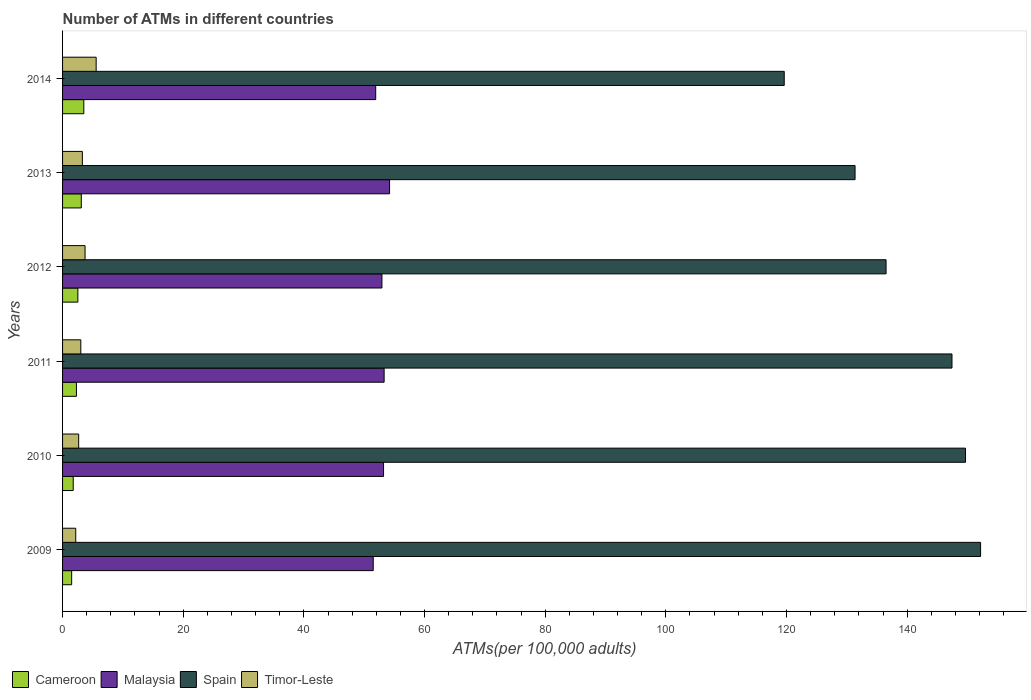How many different coloured bars are there?
Give a very brief answer. 4. Are the number of bars on each tick of the Y-axis equal?
Provide a short and direct response. Yes. How many bars are there on the 4th tick from the top?
Give a very brief answer. 4. What is the label of the 5th group of bars from the top?
Offer a terse response. 2010. In how many cases, is the number of bars for a given year not equal to the number of legend labels?
Provide a succinct answer. 0. What is the number of ATMs in Spain in 2012?
Your answer should be very brief. 136.51. Across all years, what is the maximum number of ATMs in Timor-Leste?
Ensure brevity in your answer.  5.57. Across all years, what is the minimum number of ATMs in Malaysia?
Ensure brevity in your answer.  51.5. In which year was the number of ATMs in Timor-Leste minimum?
Your response must be concise. 2009. What is the total number of ATMs in Malaysia in the graph?
Offer a terse response. 317.07. What is the difference between the number of ATMs in Malaysia in 2009 and that in 2013?
Give a very brief answer. -2.71. What is the difference between the number of ATMs in Cameroon in 2009 and the number of ATMs in Malaysia in 2014?
Your answer should be compact. -50.4. What is the average number of ATMs in Malaysia per year?
Provide a succinct answer. 52.84. In the year 2013, what is the difference between the number of ATMs in Timor-Leste and number of ATMs in Spain?
Ensure brevity in your answer.  -128.09. What is the ratio of the number of ATMs in Malaysia in 2013 to that in 2014?
Your answer should be compact. 1.04. Is the number of ATMs in Cameroon in 2009 less than that in 2013?
Offer a terse response. Yes. Is the difference between the number of ATMs in Timor-Leste in 2010 and 2013 greater than the difference between the number of ATMs in Spain in 2010 and 2013?
Your answer should be very brief. No. What is the difference between the highest and the second highest number of ATMs in Cameroon?
Make the answer very short. 0.42. What is the difference between the highest and the lowest number of ATMs in Timor-Leste?
Make the answer very short. 3.39. In how many years, is the number of ATMs in Spain greater than the average number of ATMs in Spain taken over all years?
Your response must be concise. 3. Is the sum of the number of ATMs in Cameroon in 2009 and 2014 greater than the maximum number of ATMs in Spain across all years?
Your response must be concise. No. What does the 4th bar from the top in 2010 represents?
Ensure brevity in your answer.  Cameroon. What does the 4th bar from the bottom in 2013 represents?
Provide a short and direct response. Timor-Leste. Are all the bars in the graph horizontal?
Keep it short and to the point. Yes. Does the graph contain any zero values?
Your answer should be compact. No. Where does the legend appear in the graph?
Make the answer very short. Bottom left. How many legend labels are there?
Give a very brief answer. 4. What is the title of the graph?
Keep it short and to the point. Number of ATMs in different countries. What is the label or title of the X-axis?
Offer a very short reply. ATMs(per 100,0 adults). What is the ATMs(per 100,000 adults) in Cameroon in 2009?
Ensure brevity in your answer.  1.51. What is the ATMs(per 100,000 adults) of Malaysia in 2009?
Make the answer very short. 51.5. What is the ATMs(per 100,000 adults) in Spain in 2009?
Give a very brief answer. 152.18. What is the ATMs(per 100,000 adults) of Timor-Leste in 2009?
Keep it short and to the point. 2.18. What is the ATMs(per 100,000 adults) of Cameroon in 2010?
Offer a terse response. 1.77. What is the ATMs(per 100,000 adults) in Malaysia in 2010?
Your answer should be very brief. 53.21. What is the ATMs(per 100,000 adults) in Spain in 2010?
Ensure brevity in your answer.  149.68. What is the ATMs(per 100,000 adults) of Timor-Leste in 2010?
Provide a short and direct response. 2.67. What is the ATMs(per 100,000 adults) of Cameroon in 2011?
Your answer should be compact. 2.3. What is the ATMs(per 100,000 adults) of Malaysia in 2011?
Keep it short and to the point. 53.31. What is the ATMs(per 100,000 adults) in Spain in 2011?
Keep it short and to the point. 147.44. What is the ATMs(per 100,000 adults) in Timor-Leste in 2011?
Ensure brevity in your answer.  3.02. What is the ATMs(per 100,000 adults) of Cameroon in 2012?
Your answer should be very brief. 2.53. What is the ATMs(per 100,000 adults) of Malaysia in 2012?
Provide a succinct answer. 52.94. What is the ATMs(per 100,000 adults) in Spain in 2012?
Provide a succinct answer. 136.51. What is the ATMs(per 100,000 adults) of Timor-Leste in 2012?
Offer a terse response. 3.73. What is the ATMs(per 100,000 adults) in Cameroon in 2013?
Provide a succinct answer. 3.1. What is the ATMs(per 100,000 adults) in Malaysia in 2013?
Offer a terse response. 54.21. What is the ATMs(per 100,000 adults) in Spain in 2013?
Offer a terse response. 131.37. What is the ATMs(per 100,000 adults) in Timor-Leste in 2013?
Your answer should be compact. 3.28. What is the ATMs(per 100,000 adults) in Cameroon in 2014?
Provide a short and direct response. 3.52. What is the ATMs(per 100,000 adults) in Malaysia in 2014?
Make the answer very short. 51.91. What is the ATMs(per 100,000 adults) in Spain in 2014?
Offer a very short reply. 119.63. What is the ATMs(per 100,000 adults) of Timor-Leste in 2014?
Provide a short and direct response. 5.57. Across all years, what is the maximum ATMs(per 100,000 adults) of Cameroon?
Keep it short and to the point. 3.52. Across all years, what is the maximum ATMs(per 100,000 adults) of Malaysia?
Your response must be concise. 54.21. Across all years, what is the maximum ATMs(per 100,000 adults) of Spain?
Ensure brevity in your answer.  152.18. Across all years, what is the maximum ATMs(per 100,000 adults) of Timor-Leste?
Make the answer very short. 5.57. Across all years, what is the minimum ATMs(per 100,000 adults) of Cameroon?
Ensure brevity in your answer.  1.51. Across all years, what is the minimum ATMs(per 100,000 adults) in Malaysia?
Provide a succinct answer. 51.5. Across all years, what is the minimum ATMs(per 100,000 adults) of Spain?
Offer a terse response. 119.63. Across all years, what is the minimum ATMs(per 100,000 adults) in Timor-Leste?
Offer a very short reply. 2.18. What is the total ATMs(per 100,000 adults) of Cameroon in the graph?
Give a very brief answer. 14.73. What is the total ATMs(per 100,000 adults) of Malaysia in the graph?
Your answer should be compact. 317.07. What is the total ATMs(per 100,000 adults) in Spain in the graph?
Offer a terse response. 836.8. What is the total ATMs(per 100,000 adults) of Timor-Leste in the graph?
Your answer should be very brief. 20.46. What is the difference between the ATMs(per 100,000 adults) of Cameroon in 2009 and that in 2010?
Provide a short and direct response. -0.26. What is the difference between the ATMs(per 100,000 adults) in Malaysia in 2009 and that in 2010?
Keep it short and to the point. -1.71. What is the difference between the ATMs(per 100,000 adults) of Timor-Leste in 2009 and that in 2010?
Ensure brevity in your answer.  -0.49. What is the difference between the ATMs(per 100,000 adults) in Cameroon in 2009 and that in 2011?
Your answer should be compact. -0.79. What is the difference between the ATMs(per 100,000 adults) of Malaysia in 2009 and that in 2011?
Provide a succinct answer. -1.81. What is the difference between the ATMs(per 100,000 adults) of Spain in 2009 and that in 2011?
Provide a short and direct response. 4.74. What is the difference between the ATMs(per 100,000 adults) in Timor-Leste in 2009 and that in 2011?
Provide a succinct answer. -0.84. What is the difference between the ATMs(per 100,000 adults) in Cameroon in 2009 and that in 2012?
Provide a succinct answer. -1.03. What is the difference between the ATMs(per 100,000 adults) in Malaysia in 2009 and that in 2012?
Offer a very short reply. -1.44. What is the difference between the ATMs(per 100,000 adults) of Spain in 2009 and that in 2012?
Provide a short and direct response. 15.67. What is the difference between the ATMs(per 100,000 adults) of Timor-Leste in 2009 and that in 2012?
Ensure brevity in your answer.  -1.55. What is the difference between the ATMs(per 100,000 adults) in Cameroon in 2009 and that in 2013?
Make the answer very short. -1.6. What is the difference between the ATMs(per 100,000 adults) of Malaysia in 2009 and that in 2013?
Your answer should be compact. -2.71. What is the difference between the ATMs(per 100,000 adults) in Spain in 2009 and that in 2013?
Your response must be concise. 20.81. What is the difference between the ATMs(per 100,000 adults) of Timor-Leste in 2009 and that in 2013?
Your response must be concise. -1.1. What is the difference between the ATMs(per 100,000 adults) in Cameroon in 2009 and that in 2014?
Offer a very short reply. -2.01. What is the difference between the ATMs(per 100,000 adults) in Malaysia in 2009 and that in 2014?
Your response must be concise. -0.41. What is the difference between the ATMs(per 100,000 adults) of Spain in 2009 and that in 2014?
Give a very brief answer. 32.55. What is the difference between the ATMs(per 100,000 adults) in Timor-Leste in 2009 and that in 2014?
Keep it short and to the point. -3.39. What is the difference between the ATMs(per 100,000 adults) of Cameroon in 2010 and that in 2011?
Keep it short and to the point. -0.53. What is the difference between the ATMs(per 100,000 adults) of Malaysia in 2010 and that in 2011?
Provide a short and direct response. -0.1. What is the difference between the ATMs(per 100,000 adults) in Spain in 2010 and that in 2011?
Give a very brief answer. 2.24. What is the difference between the ATMs(per 100,000 adults) of Timor-Leste in 2010 and that in 2011?
Ensure brevity in your answer.  -0.35. What is the difference between the ATMs(per 100,000 adults) of Cameroon in 2010 and that in 2012?
Provide a succinct answer. -0.77. What is the difference between the ATMs(per 100,000 adults) of Malaysia in 2010 and that in 2012?
Your answer should be compact. 0.27. What is the difference between the ATMs(per 100,000 adults) of Spain in 2010 and that in 2012?
Give a very brief answer. 13.17. What is the difference between the ATMs(per 100,000 adults) of Timor-Leste in 2010 and that in 2012?
Keep it short and to the point. -1.06. What is the difference between the ATMs(per 100,000 adults) in Cameroon in 2010 and that in 2013?
Ensure brevity in your answer.  -1.34. What is the difference between the ATMs(per 100,000 adults) of Malaysia in 2010 and that in 2013?
Your answer should be compact. -1. What is the difference between the ATMs(per 100,000 adults) in Spain in 2010 and that in 2013?
Offer a very short reply. 18.31. What is the difference between the ATMs(per 100,000 adults) of Timor-Leste in 2010 and that in 2013?
Offer a very short reply. -0.61. What is the difference between the ATMs(per 100,000 adults) in Cameroon in 2010 and that in 2014?
Give a very brief answer. -1.76. What is the difference between the ATMs(per 100,000 adults) of Malaysia in 2010 and that in 2014?
Provide a succinct answer. 1.3. What is the difference between the ATMs(per 100,000 adults) in Spain in 2010 and that in 2014?
Provide a short and direct response. 30.05. What is the difference between the ATMs(per 100,000 adults) in Timor-Leste in 2010 and that in 2014?
Your answer should be very brief. -2.9. What is the difference between the ATMs(per 100,000 adults) in Cameroon in 2011 and that in 2012?
Provide a succinct answer. -0.24. What is the difference between the ATMs(per 100,000 adults) of Malaysia in 2011 and that in 2012?
Provide a succinct answer. 0.36. What is the difference between the ATMs(per 100,000 adults) in Spain in 2011 and that in 2012?
Keep it short and to the point. 10.93. What is the difference between the ATMs(per 100,000 adults) in Timor-Leste in 2011 and that in 2012?
Offer a terse response. -0.7. What is the difference between the ATMs(per 100,000 adults) in Cameroon in 2011 and that in 2013?
Offer a terse response. -0.81. What is the difference between the ATMs(per 100,000 adults) of Malaysia in 2011 and that in 2013?
Your answer should be compact. -0.9. What is the difference between the ATMs(per 100,000 adults) in Spain in 2011 and that in 2013?
Provide a succinct answer. 16.07. What is the difference between the ATMs(per 100,000 adults) in Timor-Leste in 2011 and that in 2013?
Ensure brevity in your answer.  -0.26. What is the difference between the ATMs(per 100,000 adults) of Cameroon in 2011 and that in 2014?
Ensure brevity in your answer.  -1.22. What is the difference between the ATMs(per 100,000 adults) of Malaysia in 2011 and that in 2014?
Your answer should be compact. 1.4. What is the difference between the ATMs(per 100,000 adults) in Spain in 2011 and that in 2014?
Offer a very short reply. 27.81. What is the difference between the ATMs(per 100,000 adults) in Timor-Leste in 2011 and that in 2014?
Keep it short and to the point. -2.54. What is the difference between the ATMs(per 100,000 adults) of Cameroon in 2012 and that in 2013?
Provide a succinct answer. -0.57. What is the difference between the ATMs(per 100,000 adults) in Malaysia in 2012 and that in 2013?
Offer a terse response. -1.27. What is the difference between the ATMs(per 100,000 adults) in Spain in 2012 and that in 2013?
Your response must be concise. 5.14. What is the difference between the ATMs(per 100,000 adults) in Timor-Leste in 2012 and that in 2013?
Provide a short and direct response. 0.45. What is the difference between the ATMs(per 100,000 adults) of Cameroon in 2012 and that in 2014?
Keep it short and to the point. -0.99. What is the difference between the ATMs(per 100,000 adults) of Malaysia in 2012 and that in 2014?
Provide a short and direct response. 1.03. What is the difference between the ATMs(per 100,000 adults) in Spain in 2012 and that in 2014?
Ensure brevity in your answer.  16.88. What is the difference between the ATMs(per 100,000 adults) of Timor-Leste in 2012 and that in 2014?
Provide a succinct answer. -1.84. What is the difference between the ATMs(per 100,000 adults) of Cameroon in 2013 and that in 2014?
Your answer should be very brief. -0.42. What is the difference between the ATMs(per 100,000 adults) of Malaysia in 2013 and that in 2014?
Offer a terse response. 2.3. What is the difference between the ATMs(per 100,000 adults) in Spain in 2013 and that in 2014?
Your response must be concise. 11.74. What is the difference between the ATMs(per 100,000 adults) of Timor-Leste in 2013 and that in 2014?
Offer a very short reply. -2.29. What is the difference between the ATMs(per 100,000 adults) of Cameroon in 2009 and the ATMs(per 100,000 adults) of Malaysia in 2010?
Offer a very short reply. -51.7. What is the difference between the ATMs(per 100,000 adults) of Cameroon in 2009 and the ATMs(per 100,000 adults) of Spain in 2010?
Your answer should be compact. -148.17. What is the difference between the ATMs(per 100,000 adults) of Cameroon in 2009 and the ATMs(per 100,000 adults) of Timor-Leste in 2010?
Give a very brief answer. -1.16. What is the difference between the ATMs(per 100,000 adults) of Malaysia in 2009 and the ATMs(per 100,000 adults) of Spain in 2010?
Keep it short and to the point. -98.18. What is the difference between the ATMs(per 100,000 adults) of Malaysia in 2009 and the ATMs(per 100,000 adults) of Timor-Leste in 2010?
Keep it short and to the point. 48.83. What is the difference between the ATMs(per 100,000 adults) of Spain in 2009 and the ATMs(per 100,000 adults) of Timor-Leste in 2010?
Offer a very short reply. 149.51. What is the difference between the ATMs(per 100,000 adults) of Cameroon in 2009 and the ATMs(per 100,000 adults) of Malaysia in 2011?
Your response must be concise. -51.8. What is the difference between the ATMs(per 100,000 adults) of Cameroon in 2009 and the ATMs(per 100,000 adults) of Spain in 2011?
Keep it short and to the point. -145.93. What is the difference between the ATMs(per 100,000 adults) in Cameroon in 2009 and the ATMs(per 100,000 adults) in Timor-Leste in 2011?
Make the answer very short. -1.52. What is the difference between the ATMs(per 100,000 adults) of Malaysia in 2009 and the ATMs(per 100,000 adults) of Spain in 2011?
Your response must be concise. -95.94. What is the difference between the ATMs(per 100,000 adults) in Malaysia in 2009 and the ATMs(per 100,000 adults) in Timor-Leste in 2011?
Your answer should be compact. 48.47. What is the difference between the ATMs(per 100,000 adults) of Spain in 2009 and the ATMs(per 100,000 adults) of Timor-Leste in 2011?
Keep it short and to the point. 149.15. What is the difference between the ATMs(per 100,000 adults) of Cameroon in 2009 and the ATMs(per 100,000 adults) of Malaysia in 2012?
Provide a short and direct response. -51.43. What is the difference between the ATMs(per 100,000 adults) in Cameroon in 2009 and the ATMs(per 100,000 adults) in Spain in 2012?
Offer a very short reply. -135. What is the difference between the ATMs(per 100,000 adults) in Cameroon in 2009 and the ATMs(per 100,000 adults) in Timor-Leste in 2012?
Offer a terse response. -2.22. What is the difference between the ATMs(per 100,000 adults) of Malaysia in 2009 and the ATMs(per 100,000 adults) of Spain in 2012?
Your response must be concise. -85.01. What is the difference between the ATMs(per 100,000 adults) in Malaysia in 2009 and the ATMs(per 100,000 adults) in Timor-Leste in 2012?
Provide a succinct answer. 47.77. What is the difference between the ATMs(per 100,000 adults) in Spain in 2009 and the ATMs(per 100,000 adults) in Timor-Leste in 2012?
Your answer should be very brief. 148.45. What is the difference between the ATMs(per 100,000 adults) in Cameroon in 2009 and the ATMs(per 100,000 adults) in Malaysia in 2013?
Your answer should be compact. -52.7. What is the difference between the ATMs(per 100,000 adults) in Cameroon in 2009 and the ATMs(per 100,000 adults) in Spain in 2013?
Ensure brevity in your answer.  -129.86. What is the difference between the ATMs(per 100,000 adults) in Cameroon in 2009 and the ATMs(per 100,000 adults) in Timor-Leste in 2013?
Give a very brief answer. -1.77. What is the difference between the ATMs(per 100,000 adults) in Malaysia in 2009 and the ATMs(per 100,000 adults) in Spain in 2013?
Your answer should be compact. -79.87. What is the difference between the ATMs(per 100,000 adults) in Malaysia in 2009 and the ATMs(per 100,000 adults) in Timor-Leste in 2013?
Make the answer very short. 48.22. What is the difference between the ATMs(per 100,000 adults) in Spain in 2009 and the ATMs(per 100,000 adults) in Timor-Leste in 2013?
Offer a terse response. 148.9. What is the difference between the ATMs(per 100,000 adults) of Cameroon in 2009 and the ATMs(per 100,000 adults) of Malaysia in 2014?
Give a very brief answer. -50.4. What is the difference between the ATMs(per 100,000 adults) in Cameroon in 2009 and the ATMs(per 100,000 adults) in Spain in 2014?
Offer a terse response. -118.12. What is the difference between the ATMs(per 100,000 adults) of Cameroon in 2009 and the ATMs(per 100,000 adults) of Timor-Leste in 2014?
Give a very brief answer. -4.06. What is the difference between the ATMs(per 100,000 adults) in Malaysia in 2009 and the ATMs(per 100,000 adults) in Spain in 2014?
Your response must be concise. -68.13. What is the difference between the ATMs(per 100,000 adults) in Malaysia in 2009 and the ATMs(per 100,000 adults) in Timor-Leste in 2014?
Offer a very short reply. 45.93. What is the difference between the ATMs(per 100,000 adults) of Spain in 2009 and the ATMs(per 100,000 adults) of Timor-Leste in 2014?
Keep it short and to the point. 146.61. What is the difference between the ATMs(per 100,000 adults) of Cameroon in 2010 and the ATMs(per 100,000 adults) of Malaysia in 2011?
Offer a terse response. -51.54. What is the difference between the ATMs(per 100,000 adults) of Cameroon in 2010 and the ATMs(per 100,000 adults) of Spain in 2011?
Your response must be concise. -145.67. What is the difference between the ATMs(per 100,000 adults) in Cameroon in 2010 and the ATMs(per 100,000 adults) in Timor-Leste in 2011?
Ensure brevity in your answer.  -1.26. What is the difference between the ATMs(per 100,000 adults) of Malaysia in 2010 and the ATMs(per 100,000 adults) of Spain in 2011?
Provide a succinct answer. -94.23. What is the difference between the ATMs(per 100,000 adults) in Malaysia in 2010 and the ATMs(per 100,000 adults) in Timor-Leste in 2011?
Ensure brevity in your answer.  50.18. What is the difference between the ATMs(per 100,000 adults) in Spain in 2010 and the ATMs(per 100,000 adults) in Timor-Leste in 2011?
Provide a short and direct response. 146.65. What is the difference between the ATMs(per 100,000 adults) of Cameroon in 2010 and the ATMs(per 100,000 adults) of Malaysia in 2012?
Offer a terse response. -51.18. What is the difference between the ATMs(per 100,000 adults) in Cameroon in 2010 and the ATMs(per 100,000 adults) in Spain in 2012?
Offer a terse response. -134.74. What is the difference between the ATMs(per 100,000 adults) in Cameroon in 2010 and the ATMs(per 100,000 adults) in Timor-Leste in 2012?
Offer a very short reply. -1.96. What is the difference between the ATMs(per 100,000 adults) of Malaysia in 2010 and the ATMs(per 100,000 adults) of Spain in 2012?
Offer a terse response. -83.3. What is the difference between the ATMs(per 100,000 adults) in Malaysia in 2010 and the ATMs(per 100,000 adults) in Timor-Leste in 2012?
Offer a terse response. 49.48. What is the difference between the ATMs(per 100,000 adults) of Spain in 2010 and the ATMs(per 100,000 adults) of Timor-Leste in 2012?
Your answer should be compact. 145.95. What is the difference between the ATMs(per 100,000 adults) of Cameroon in 2010 and the ATMs(per 100,000 adults) of Malaysia in 2013?
Offer a very short reply. -52.44. What is the difference between the ATMs(per 100,000 adults) in Cameroon in 2010 and the ATMs(per 100,000 adults) in Spain in 2013?
Keep it short and to the point. -129.6. What is the difference between the ATMs(per 100,000 adults) in Cameroon in 2010 and the ATMs(per 100,000 adults) in Timor-Leste in 2013?
Provide a succinct answer. -1.52. What is the difference between the ATMs(per 100,000 adults) in Malaysia in 2010 and the ATMs(per 100,000 adults) in Spain in 2013?
Offer a terse response. -78.16. What is the difference between the ATMs(per 100,000 adults) in Malaysia in 2010 and the ATMs(per 100,000 adults) in Timor-Leste in 2013?
Give a very brief answer. 49.93. What is the difference between the ATMs(per 100,000 adults) of Spain in 2010 and the ATMs(per 100,000 adults) of Timor-Leste in 2013?
Provide a succinct answer. 146.4. What is the difference between the ATMs(per 100,000 adults) of Cameroon in 2010 and the ATMs(per 100,000 adults) of Malaysia in 2014?
Provide a succinct answer. -50.14. What is the difference between the ATMs(per 100,000 adults) of Cameroon in 2010 and the ATMs(per 100,000 adults) of Spain in 2014?
Offer a very short reply. -117.86. What is the difference between the ATMs(per 100,000 adults) in Cameroon in 2010 and the ATMs(per 100,000 adults) in Timor-Leste in 2014?
Make the answer very short. -3.8. What is the difference between the ATMs(per 100,000 adults) of Malaysia in 2010 and the ATMs(per 100,000 adults) of Spain in 2014?
Your answer should be very brief. -66.42. What is the difference between the ATMs(per 100,000 adults) of Malaysia in 2010 and the ATMs(per 100,000 adults) of Timor-Leste in 2014?
Provide a succinct answer. 47.64. What is the difference between the ATMs(per 100,000 adults) of Spain in 2010 and the ATMs(per 100,000 adults) of Timor-Leste in 2014?
Ensure brevity in your answer.  144.11. What is the difference between the ATMs(per 100,000 adults) in Cameroon in 2011 and the ATMs(per 100,000 adults) in Malaysia in 2012?
Provide a short and direct response. -50.64. What is the difference between the ATMs(per 100,000 adults) in Cameroon in 2011 and the ATMs(per 100,000 adults) in Spain in 2012?
Offer a very short reply. -134.21. What is the difference between the ATMs(per 100,000 adults) of Cameroon in 2011 and the ATMs(per 100,000 adults) of Timor-Leste in 2012?
Provide a succinct answer. -1.43. What is the difference between the ATMs(per 100,000 adults) in Malaysia in 2011 and the ATMs(per 100,000 adults) in Spain in 2012?
Give a very brief answer. -83.2. What is the difference between the ATMs(per 100,000 adults) of Malaysia in 2011 and the ATMs(per 100,000 adults) of Timor-Leste in 2012?
Give a very brief answer. 49.58. What is the difference between the ATMs(per 100,000 adults) of Spain in 2011 and the ATMs(per 100,000 adults) of Timor-Leste in 2012?
Your response must be concise. 143.71. What is the difference between the ATMs(per 100,000 adults) in Cameroon in 2011 and the ATMs(per 100,000 adults) in Malaysia in 2013?
Provide a succinct answer. -51.91. What is the difference between the ATMs(per 100,000 adults) of Cameroon in 2011 and the ATMs(per 100,000 adults) of Spain in 2013?
Your response must be concise. -129.07. What is the difference between the ATMs(per 100,000 adults) in Cameroon in 2011 and the ATMs(per 100,000 adults) in Timor-Leste in 2013?
Your response must be concise. -0.98. What is the difference between the ATMs(per 100,000 adults) in Malaysia in 2011 and the ATMs(per 100,000 adults) in Spain in 2013?
Offer a terse response. -78.06. What is the difference between the ATMs(per 100,000 adults) in Malaysia in 2011 and the ATMs(per 100,000 adults) in Timor-Leste in 2013?
Keep it short and to the point. 50.02. What is the difference between the ATMs(per 100,000 adults) in Spain in 2011 and the ATMs(per 100,000 adults) in Timor-Leste in 2013?
Give a very brief answer. 144.15. What is the difference between the ATMs(per 100,000 adults) of Cameroon in 2011 and the ATMs(per 100,000 adults) of Malaysia in 2014?
Give a very brief answer. -49.61. What is the difference between the ATMs(per 100,000 adults) of Cameroon in 2011 and the ATMs(per 100,000 adults) of Spain in 2014?
Provide a short and direct response. -117.33. What is the difference between the ATMs(per 100,000 adults) in Cameroon in 2011 and the ATMs(per 100,000 adults) in Timor-Leste in 2014?
Give a very brief answer. -3.27. What is the difference between the ATMs(per 100,000 adults) of Malaysia in 2011 and the ATMs(per 100,000 adults) of Spain in 2014?
Keep it short and to the point. -66.32. What is the difference between the ATMs(per 100,000 adults) in Malaysia in 2011 and the ATMs(per 100,000 adults) in Timor-Leste in 2014?
Make the answer very short. 47.74. What is the difference between the ATMs(per 100,000 adults) in Spain in 2011 and the ATMs(per 100,000 adults) in Timor-Leste in 2014?
Provide a short and direct response. 141.87. What is the difference between the ATMs(per 100,000 adults) of Cameroon in 2012 and the ATMs(per 100,000 adults) of Malaysia in 2013?
Make the answer very short. -51.67. What is the difference between the ATMs(per 100,000 adults) in Cameroon in 2012 and the ATMs(per 100,000 adults) in Spain in 2013?
Provide a short and direct response. -128.83. What is the difference between the ATMs(per 100,000 adults) in Cameroon in 2012 and the ATMs(per 100,000 adults) in Timor-Leste in 2013?
Make the answer very short. -0.75. What is the difference between the ATMs(per 100,000 adults) in Malaysia in 2012 and the ATMs(per 100,000 adults) in Spain in 2013?
Your answer should be compact. -78.43. What is the difference between the ATMs(per 100,000 adults) of Malaysia in 2012 and the ATMs(per 100,000 adults) of Timor-Leste in 2013?
Provide a succinct answer. 49.66. What is the difference between the ATMs(per 100,000 adults) in Spain in 2012 and the ATMs(per 100,000 adults) in Timor-Leste in 2013?
Provide a short and direct response. 133.23. What is the difference between the ATMs(per 100,000 adults) in Cameroon in 2012 and the ATMs(per 100,000 adults) in Malaysia in 2014?
Make the answer very short. -49.37. What is the difference between the ATMs(per 100,000 adults) of Cameroon in 2012 and the ATMs(per 100,000 adults) of Spain in 2014?
Give a very brief answer. -117.09. What is the difference between the ATMs(per 100,000 adults) of Cameroon in 2012 and the ATMs(per 100,000 adults) of Timor-Leste in 2014?
Give a very brief answer. -3.03. What is the difference between the ATMs(per 100,000 adults) of Malaysia in 2012 and the ATMs(per 100,000 adults) of Spain in 2014?
Ensure brevity in your answer.  -66.69. What is the difference between the ATMs(per 100,000 adults) in Malaysia in 2012 and the ATMs(per 100,000 adults) in Timor-Leste in 2014?
Your answer should be very brief. 47.37. What is the difference between the ATMs(per 100,000 adults) in Spain in 2012 and the ATMs(per 100,000 adults) in Timor-Leste in 2014?
Give a very brief answer. 130.94. What is the difference between the ATMs(per 100,000 adults) of Cameroon in 2013 and the ATMs(per 100,000 adults) of Malaysia in 2014?
Make the answer very short. -48.8. What is the difference between the ATMs(per 100,000 adults) in Cameroon in 2013 and the ATMs(per 100,000 adults) in Spain in 2014?
Provide a succinct answer. -116.52. What is the difference between the ATMs(per 100,000 adults) of Cameroon in 2013 and the ATMs(per 100,000 adults) of Timor-Leste in 2014?
Your answer should be very brief. -2.46. What is the difference between the ATMs(per 100,000 adults) in Malaysia in 2013 and the ATMs(per 100,000 adults) in Spain in 2014?
Ensure brevity in your answer.  -65.42. What is the difference between the ATMs(per 100,000 adults) of Malaysia in 2013 and the ATMs(per 100,000 adults) of Timor-Leste in 2014?
Offer a very short reply. 48.64. What is the difference between the ATMs(per 100,000 adults) of Spain in 2013 and the ATMs(per 100,000 adults) of Timor-Leste in 2014?
Keep it short and to the point. 125.8. What is the average ATMs(per 100,000 adults) of Cameroon per year?
Keep it short and to the point. 2.46. What is the average ATMs(per 100,000 adults) of Malaysia per year?
Make the answer very short. 52.84. What is the average ATMs(per 100,000 adults) of Spain per year?
Offer a terse response. 139.47. What is the average ATMs(per 100,000 adults) of Timor-Leste per year?
Your response must be concise. 3.41. In the year 2009, what is the difference between the ATMs(per 100,000 adults) of Cameroon and ATMs(per 100,000 adults) of Malaysia?
Your answer should be very brief. -49.99. In the year 2009, what is the difference between the ATMs(per 100,000 adults) of Cameroon and ATMs(per 100,000 adults) of Spain?
Ensure brevity in your answer.  -150.67. In the year 2009, what is the difference between the ATMs(per 100,000 adults) of Cameroon and ATMs(per 100,000 adults) of Timor-Leste?
Ensure brevity in your answer.  -0.67. In the year 2009, what is the difference between the ATMs(per 100,000 adults) in Malaysia and ATMs(per 100,000 adults) in Spain?
Your answer should be very brief. -100.68. In the year 2009, what is the difference between the ATMs(per 100,000 adults) in Malaysia and ATMs(per 100,000 adults) in Timor-Leste?
Your answer should be compact. 49.32. In the year 2009, what is the difference between the ATMs(per 100,000 adults) of Spain and ATMs(per 100,000 adults) of Timor-Leste?
Make the answer very short. 150. In the year 2010, what is the difference between the ATMs(per 100,000 adults) of Cameroon and ATMs(per 100,000 adults) of Malaysia?
Offer a terse response. -51.44. In the year 2010, what is the difference between the ATMs(per 100,000 adults) in Cameroon and ATMs(per 100,000 adults) in Spain?
Provide a short and direct response. -147.91. In the year 2010, what is the difference between the ATMs(per 100,000 adults) of Cameroon and ATMs(per 100,000 adults) of Timor-Leste?
Make the answer very short. -0.91. In the year 2010, what is the difference between the ATMs(per 100,000 adults) of Malaysia and ATMs(per 100,000 adults) of Spain?
Give a very brief answer. -96.47. In the year 2010, what is the difference between the ATMs(per 100,000 adults) of Malaysia and ATMs(per 100,000 adults) of Timor-Leste?
Provide a succinct answer. 50.54. In the year 2010, what is the difference between the ATMs(per 100,000 adults) of Spain and ATMs(per 100,000 adults) of Timor-Leste?
Keep it short and to the point. 147.01. In the year 2011, what is the difference between the ATMs(per 100,000 adults) in Cameroon and ATMs(per 100,000 adults) in Malaysia?
Keep it short and to the point. -51.01. In the year 2011, what is the difference between the ATMs(per 100,000 adults) in Cameroon and ATMs(per 100,000 adults) in Spain?
Your answer should be compact. -145.14. In the year 2011, what is the difference between the ATMs(per 100,000 adults) of Cameroon and ATMs(per 100,000 adults) of Timor-Leste?
Ensure brevity in your answer.  -0.73. In the year 2011, what is the difference between the ATMs(per 100,000 adults) of Malaysia and ATMs(per 100,000 adults) of Spain?
Offer a terse response. -94.13. In the year 2011, what is the difference between the ATMs(per 100,000 adults) in Malaysia and ATMs(per 100,000 adults) in Timor-Leste?
Provide a succinct answer. 50.28. In the year 2011, what is the difference between the ATMs(per 100,000 adults) in Spain and ATMs(per 100,000 adults) in Timor-Leste?
Offer a very short reply. 144.41. In the year 2012, what is the difference between the ATMs(per 100,000 adults) in Cameroon and ATMs(per 100,000 adults) in Malaysia?
Provide a succinct answer. -50.41. In the year 2012, what is the difference between the ATMs(per 100,000 adults) of Cameroon and ATMs(per 100,000 adults) of Spain?
Your response must be concise. -133.97. In the year 2012, what is the difference between the ATMs(per 100,000 adults) in Cameroon and ATMs(per 100,000 adults) in Timor-Leste?
Keep it short and to the point. -1.2. In the year 2012, what is the difference between the ATMs(per 100,000 adults) of Malaysia and ATMs(per 100,000 adults) of Spain?
Your response must be concise. -83.57. In the year 2012, what is the difference between the ATMs(per 100,000 adults) of Malaysia and ATMs(per 100,000 adults) of Timor-Leste?
Offer a terse response. 49.21. In the year 2012, what is the difference between the ATMs(per 100,000 adults) of Spain and ATMs(per 100,000 adults) of Timor-Leste?
Provide a short and direct response. 132.78. In the year 2013, what is the difference between the ATMs(per 100,000 adults) of Cameroon and ATMs(per 100,000 adults) of Malaysia?
Keep it short and to the point. -51.1. In the year 2013, what is the difference between the ATMs(per 100,000 adults) in Cameroon and ATMs(per 100,000 adults) in Spain?
Provide a succinct answer. -128.26. In the year 2013, what is the difference between the ATMs(per 100,000 adults) in Cameroon and ATMs(per 100,000 adults) in Timor-Leste?
Give a very brief answer. -0.18. In the year 2013, what is the difference between the ATMs(per 100,000 adults) in Malaysia and ATMs(per 100,000 adults) in Spain?
Your answer should be very brief. -77.16. In the year 2013, what is the difference between the ATMs(per 100,000 adults) of Malaysia and ATMs(per 100,000 adults) of Timor-Leste?
Offer a terse response. 50.92. In the year 2013, what is the difference between the ATMs(per 100,000 adults) in Spain and ATMs(per 100,000 adults) in Timor-Leste?
Your response must be concise. 128.09. In the year 2014, what is the difference between the ATMs(per 100,000 adults) in Cameroon and ATMs(per 100,000 adults) in Malaysia?
Make the answer very short. -48.39. In the year 2014, what is the difference between the ATMs(per 100,000 adults) of Cameroon and ATMs(per 100,000 adults) of Spain?
Offer a very short reply. -116.11. In the year 2014, what is the difference between the ATMs(per 100,000 adults) in Cameroon and ATMs(per 100,000 adults) in Timor-Leste?
Give a very brief answer. -2.05. In the year 2014, what is the difference between the ATMs(per 100,000 adults) in Malaysia and ATMs(per 100,000 adults) in Spain?
Keep it short and to the point. -67.72. In the year 2014, what is the difference between the ATMs(per 100,000 adults) in Malaysia and ATMs(per 100,000 adults) in Timor-Leste?
Provide a succinct answer. 46.34. In the year 2014, what is the difference between the ATMs(per 100,000 adults) in Spain and ATMs(per 100,000 adults) in Timor-Leste?
Your answer should be compact. 114.06. What is the ratio of the ATMs(per 100,000 adults) of Cameroon in 2009 to that in 2010?
Give a very brief answer. 0.85. What is the ratio of the ATMs(per 100,000 adults) in Malaysia in 2009 to that in 2010?
Provide a succinct answer. 0.97. What is the ratio of the ATMs(per 100,000 adults) of Spain in 2009 to that in 2010?
Your response must be concise. 1.02. What is the ratio of the ATMs(per 100,000 adults) of Timor-Leste in 2009 to that in 2010?
Ensure brevity in your answer.  0.82. What is the ratio of the ATMs(per 100,000 adults) of Cameroon in 2009 to that in 2011?
Offer a terse response. 0.66. What is the ratio of the ATMs(per 100,000 adults) of Malaysia in 2009 to that in 2011?
Keep it short and to the point. 0.97. What is the ratio of the ATMs(per 100,000 adults) of Spain in 2009 to that in 2011?
Your response must be concise. 1.03. What is the ratio of the ATMs(per 100,000 adults) in Timor-Leste in 2009 to that in 2011?
Ensure brevity in your answer.  0.72. What is the ratio of the ATMs(per 100,000 adults) of Cameroon in 2009 to that in 2012?
Give a very brief answer. 0.59. What is the ratio of the ATMs(per 100,000 adults) in Malaysia in 2009 to that in 2012?
Your answer should be compact. 0.97. What is the ratio of the ATMs(per 100,000 adults) in Spain in 2009 to that in 2012?
Provide a succinct answer. 1.11. What is the ratio of the ATMs(per 100,000 adults) of Timor-Leste in 2009 to that in 2012?
Your response must be concise. 0.58. What is the ratio of the ATMs(per 100,000 adults) in Cameroon in 2009 to that in 2013?
Keep it short and to the point. 0.49. What is the ratio of the ATMs(per 100,000 adults) in Malaysia in 2009 to that in 2013?
Your answer should be compact. 0.95. What is the ratio of the ATMs(per 100,000 adults) in Spain in 2009 to that in 2013?
Ensure brevity in your answer.  1.16. What is the ratio of the ATMs(per 100,000 adults) in Timor-Leste in 2009 to that in 2013?
Give a very brief answer. 0.66. What is the ratio of the ATMs(per 100,000 adults) of Cameroon in 2009 to that in 2014?
Offer a very short reply. 0.43. What is the ratio of the ATMs(per 100,000 adults) in Spain in 2009 to that in 2014?
Make the answer very short. 1.27. What is the ratio of the ATMs(per 100,000 adults) in Timor-Leste in 2009 to that in 2014?
Your answer should be compact. 0.39. What is the ratio of the ATMs(per 100,000 adults) in Cameroon in 2010 to that in 2011?
Provide a short and direct response. 0.77. What is the ratio of the ATMs(per 100,000 adults) of Spain in 2010 to that in 2011?
Give a very brief answer. 1.02. What is the ratio of the ATMs(per 100,000 adults) of Timor-Leste in 2010 to that in 2011?
Offer a terse response. 0.88. What is the ratio of the ATMs(per 100,000 adults) in Cameroon in 2010 to that in 2012?
Ensure brevity in your answer.  0.7. What is the ratio of the ATMs(per 100,000 adults) of Malaysia in 2010 to that in 2012?
Make the answer very short. 1. What is the ratio of the ATMs(per 100,000 adults) of Spain in 2010 to that in 2012?
Your answer should be compact. 1.1. What is the ratio of the ATMs(per 100,000 adults) in Timor-Leste in 2010 to that in 2012?
Your answer should be compact. 0.72. What is the ratio of the ATMs(per 100,000 adults) of Cameroon in 2010 to that in 2013?
Keep it short and to the point. 0.57. What is the ratio of the ATMs(per 100,000 adults) in Malaysia in 2010 to that in 2013?
Offer a terse response. 0.98. What is the ratio of the ATMs(per 100,000 adults) in Spain in 2010 to that in 2013?
Provide a short and direct response. 1.14. What is the ratio of the ATMs(per 100,000 adults) in Timor-Leste in 2010 to that in 2013?
Your answer should be compact. 0.81. What is the ratio of the ATMs(per 100,000 adults) in Cameroon in 2010 to that in 2014?
Your answer should be compact. 0.5. What is the ratio of the ATMs(per 100,000 adults) of Spain in 2010 to that in 2014?
Offer a terse response. 1.25. What is the ratio of the ATMs(per 100,000 adults) in Timor-Leste in 2010 to that in 2014?
Make the answer very short. 0.48. What is the ratio of the ATMs(per 100,000 adults) in Cameroon in 2011 to that in 2012?
Provide a succinct answer. 0.91. What is the ratio of the ATMs(per 100,000 adults) of Timor-Leste in 2011 to that in 2012?
Keep it short and to the point. 0.81. What is the ratio of the ATMs(per 100,000 adults) in Cameroon in 2011 to that in 2013?
Keep it short and to the point. 0.74. What is the ratio of the ATMs(per 100,000 adults) of Malaysia in 2011 to that in 2013?
Provide a short and direct response. 0.98. What is the ratio of the ATMs(per 100,000 adults) in Spain in 2011 to that in 2013?
Give a very brief answer. 1.12. What is the ratio of the ATMs(per 100,000 adults) in Timor-Leste in 2011 to that in 2013?
Make the answer very short. 0.92. What is the ratio of the ATMs(per 100,000 adults) of Cameroon in 2011 to that in 2014?
Provide a succinct answer. 0.65. What is the ratio of the ATMs(per 100,000 adults) in Malaysia in 2011 to that in 2014?
Offer a terse response. 1.03. What is the ratio of the ATMs(per 100,000 adults) in Spain in 2011 to that in 2014?
Give a very brief answer. 1.23. What is the ratio of the ATMs(per 100,000 adults) in Timor-Leste in 2011 to that in 2014?
Provide a succinct answer. 0.54. What is the ratio of the ATMs(per 100,000 adults) in Cameroon in 2012 to that in 2013?
Keep it short and to the point. 0.82. What is the ratio of the ATMs(per 100,000 adults) in Malaysia in 2012 to that in 2013?
Your answer should be compact. 0.98. What is the ratio of the ATMs(per 100,000 adults) in Spain in 2012 to that in 2013?
Keep it short and to the point. 1.04. What is the ratio of the ATMs(per 100,000 adults) in Timor-Leste in 2012 to that in 2013?
Offer a very short reply. 1.14. What is the ratio of the ATMs(per 100,000 adults) of Cameroon in 2012 to that in 2014?
Make the answer very short. 0.72. What is the ratio of the ATMs(per 100,000 adults) of Malaysia in 2012 to that in 2014?
Your response must be concise. 1.02. What is the ratio of the ATMs(per 100,000 adults) of Spain in 2012 to that in 2014?
Your answer should be compact. 1.14. What is the ratio of the ATMs(per 100,000 adults) in Timor-Leste in 2012 to that in 2014?
Ensure brevity in your answer.  0.67. What is the ratio of the ATMs(per 100,000 adults) of Cameroon in 2013 to that in 2014?
Your response must be concise. 0.88. What is the ratio of the ATMs(per 100,000 adults) of Malaysia in 2013 to that in 2014?
Your answer should be compact. 1.04. What is the ratio of the ATMs(per 100,000 adults) of Spain in 2013 to that in 2014?
Provide a short and direct response. 1.1. What is the ratio of the ATMs(per 100,000 adults) of Timor-Leste in 2013 to that in 2014?
Make the answer very short. 0.59. What is the difference between the highest and the second highest ATMs(per 100,000 adults) of Cameroon?
Your answer should be compact. 0.42. What is the difference between the highest and the second highest ATMs(per 100,000 adults) of Malaysia?
Provide a short and direct response. 0.9. What is the difference between the highest and the second highest ATMs(per 100,000 adults) in Spain?
Offer a very short reply. 2.5. What is the difference between the highest and the second highest ATMs(per 100,000 adults) of Timor-Leste?
Ensure brevity in your answer.  1.84. What is the difference between the highest and the lowest ATMs(per 100,000 adults) of Cameroon?
Provide a short and direct response. 2.01. What is the difference between the highest and the lowest ATMs(per 100,000 adults) of Malaysia?
Give a very brief answer. 2.71. What is the difference between the highest and the lowest ATMs(per 100,000 adults) in Spain?
Give a very brief answer. 32.55. What is the difference between the highest and the lowest ATMs(per 100,000 adults) of Timor-Leste?
Your response must be concise. 3.39. 